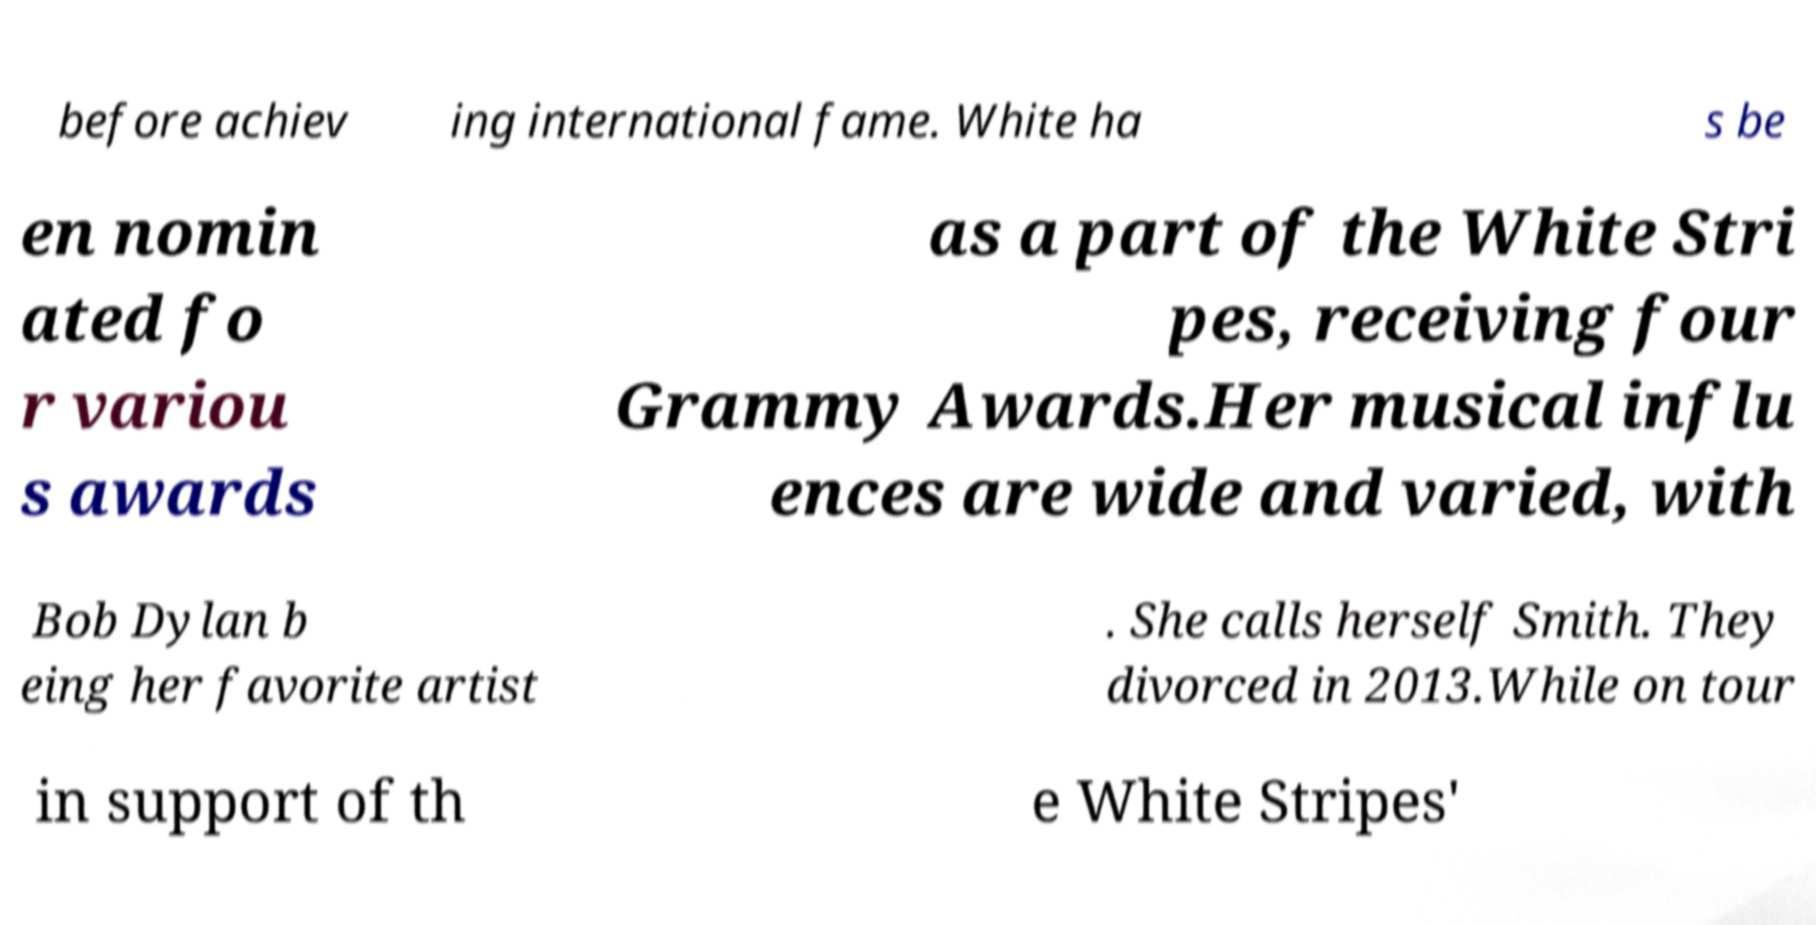Please read and relay the text visible in this image. What does it say? before achiev ing international fame. White ha s be en nomin ated fo r variou s awards as a part of the White Stri pes, receiving four Grammy Awards.Her musical influ ences are wide and varied, with Bob Dylan b eing her favorite artist . She calls herself Smith. They divorced in 2013.While on tour in support of th e White Stripes' 